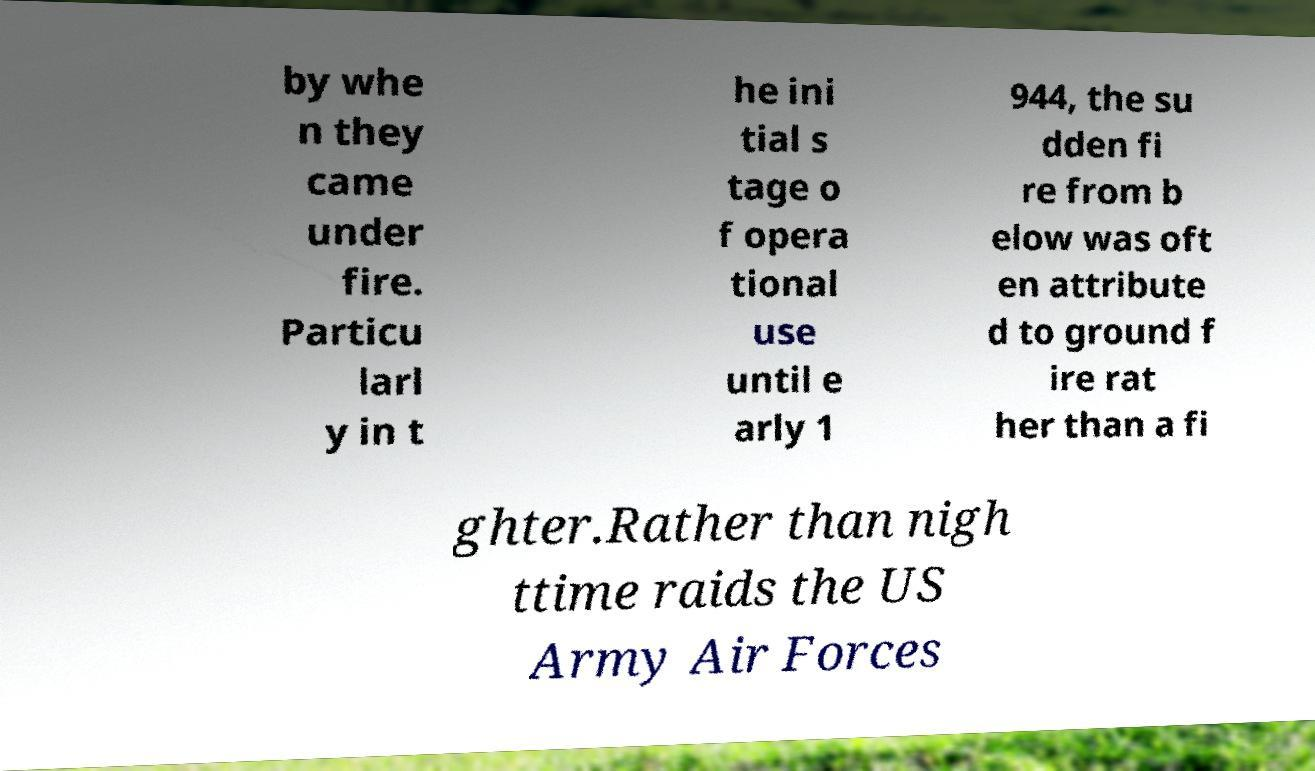Please identify and transcribe the text found in this image. by whe n they came under fire. Particu larl y in t he ini tial s tage o f opera tional use until e arly 1 944, the su dden fi re from b elow was oft en attribute d to ground f ire rat her than a fi ghter.Rather than nigh ttime raids the US Army Air Forces 